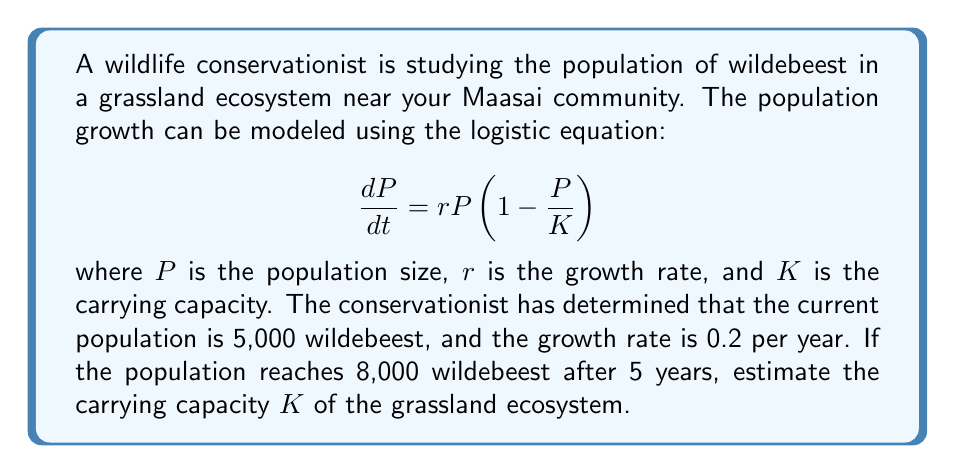Can you solve this math problem? To solve this problem, we need to use the solution to the logistic growth equation:

$$P(t) = \frac{K}{1 + \left(\frac{K}{P_0} - 1\right)e^{-rt}}$$

Where:
- $P(t)$ is the population at time $t$
- $P_0$ is the initial population
- $K$ is the carrying capacity
- $r$ is the growth rate
- $t$ is the time

We know:
- $P_0 = 5,000$ (initial population)
- $r = 0.2$ (growth rate)
- $t = 5$ (years)
- $P(5) = 8,000$ (population after 5 years)

Let's substitute these values into the equation:

$$8,000 = \frac{K}{1 + \left(\frac{K}{5,000} - 1\right)e^{-0.2 \cdot 5}}$$

Simplify the exponent:
$$8,000 = \frac{K}{1 + \left(\frac{K}{5,000} - 1\right)e^{-1}}$$

Now, let's solve for $K$:

1) Multiply both sides by the denominator:
   $$8,000 + 8,000\left(\frac{K}{5,000} - 1\right)e^{-1} = K$$

2) Expand:
   $$8,000 + 1.6K e^{-1} - 8,000e^{-1} = K$$

3) Rearrange:
   $$K - 1.6K e^{-1} = 8,000 - 8,000e^{-1}$$

4) Factor out $K$:
   $$K(1 - 1.6e^{-1}) = 8,000(1 - e^{-1})$$

5) Solve for $K$:
   $$K = \frac{8,000(1 - e^{-1})}{1 - 1.6e^{-1}}$$

6) Calculate the value (using a calculator):
   $$K \approx 10,526$$

Therefore, the estimated carrying capacity of the grassland ecosystem is approximately 10,526 wildebeest.
Answer: The estimated carrying capacity $K$ of the grassland ecosystem is approximately 10,526 wildebeest. 